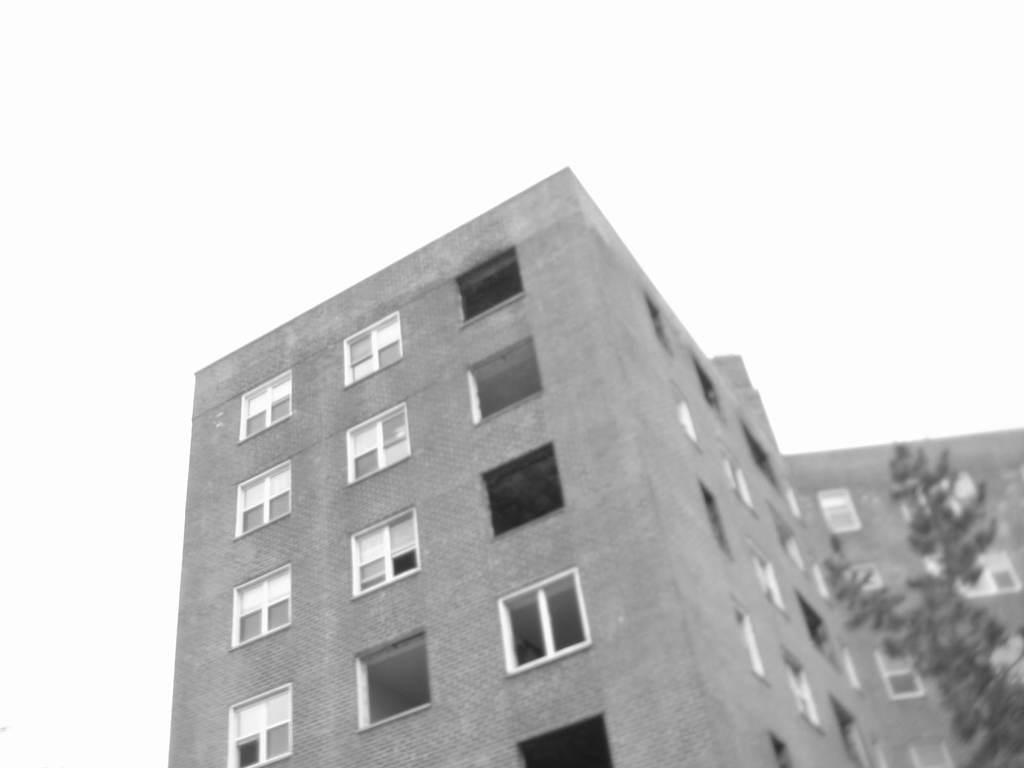What type of natural element is present in the image? There is a tree in the image. What type of man-made structure is present in the image? There is a building with windows in the image. What color is the background of the image? The background of the image appears to be white. What type of metal is being washed in the image? There is no metal or washing activity present in the image. 